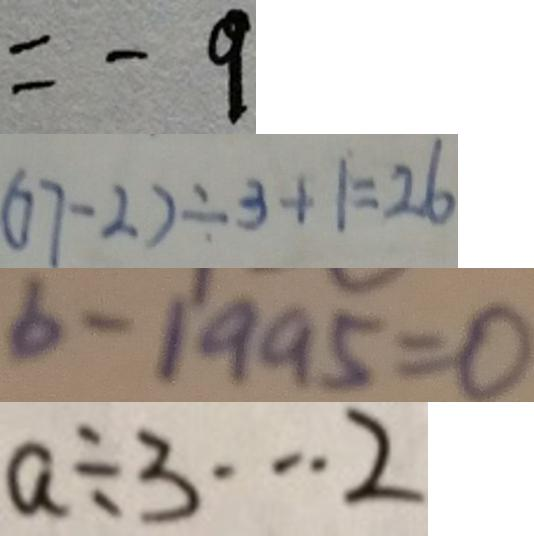Convert formula to latex. <formula><loc_0><loc_0><loc_500><loc_500>= - 9 
 ( 7 7 - 2 ) \div 3 + 1 = 2 6 
 b - 1 9 9 5 = 0 
 a \div 3 \cdots 2</formula> 